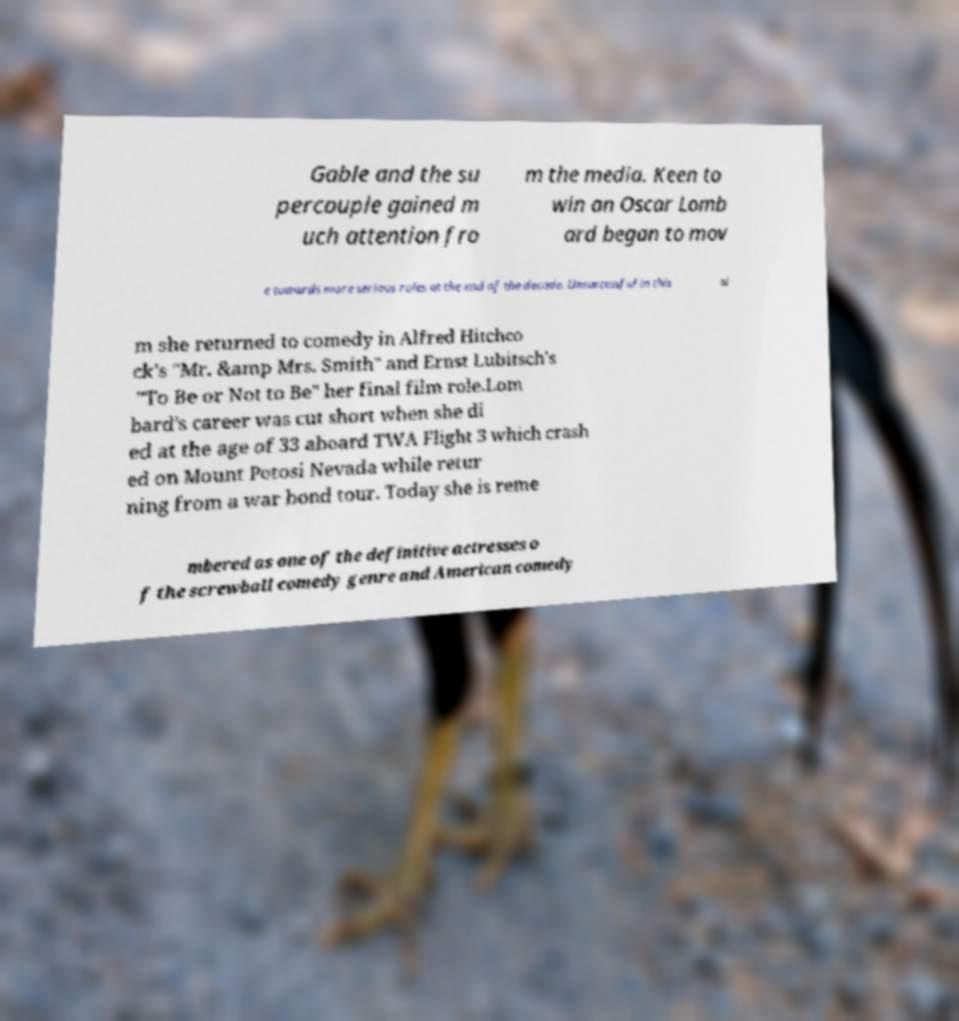Please identify and transcribe the text found in this image. Gable and the su percouple gained m uch attention fro m the media. Keen to win an Oscar Lomb ard began to mov e towards more serious roles at the end of the decade. Unsuccessful in this ai m she returned to comedy in Alfred Hitchco ck's "Mr. &amp Mrs. Smith" and Ernst Lubitsch's "To Be or Not to Be" her final film role.Lom bard's career was cut short when she di ed at the age of 33 aboard TWA Flight 3 which crash ed on Mount Potosi Nevada while retur ning from a war bond tour. Today she is reme mbered as one of the definitive actresses o f the screwball comedy genre and American comedy 